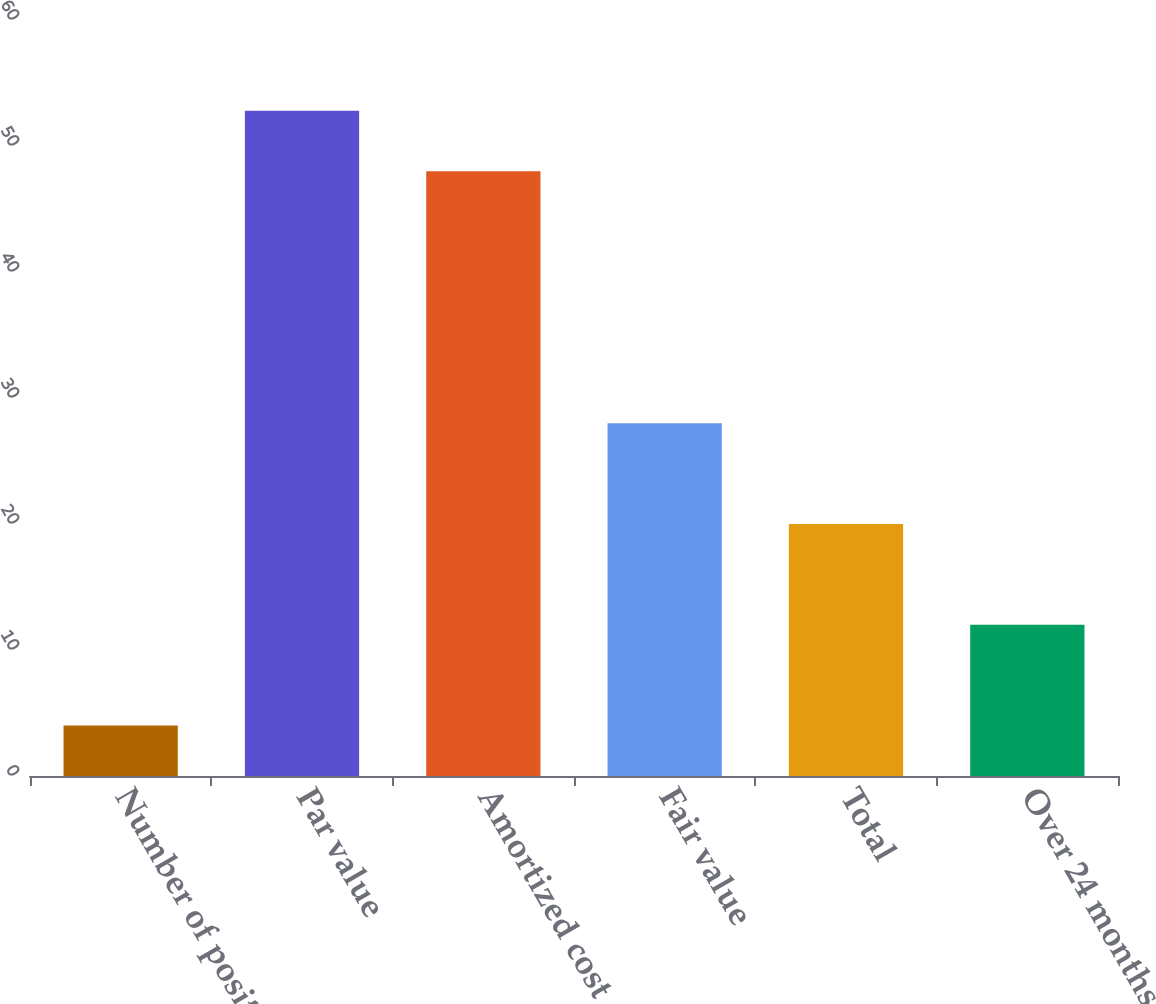Convert chart. <chart><loc_0><loc_0><loc_500><loc_500><bar_chart><fcel>Number of positions<fcel>Par value<fcel>Amortized cost<fcel>Fair value<fcel>Total<fcel>Over 24 months (5)<nl><fcel>4<fcel>52.8<fcel>48<fcel>28<fcel>20<fcel>12<nl></chart> 